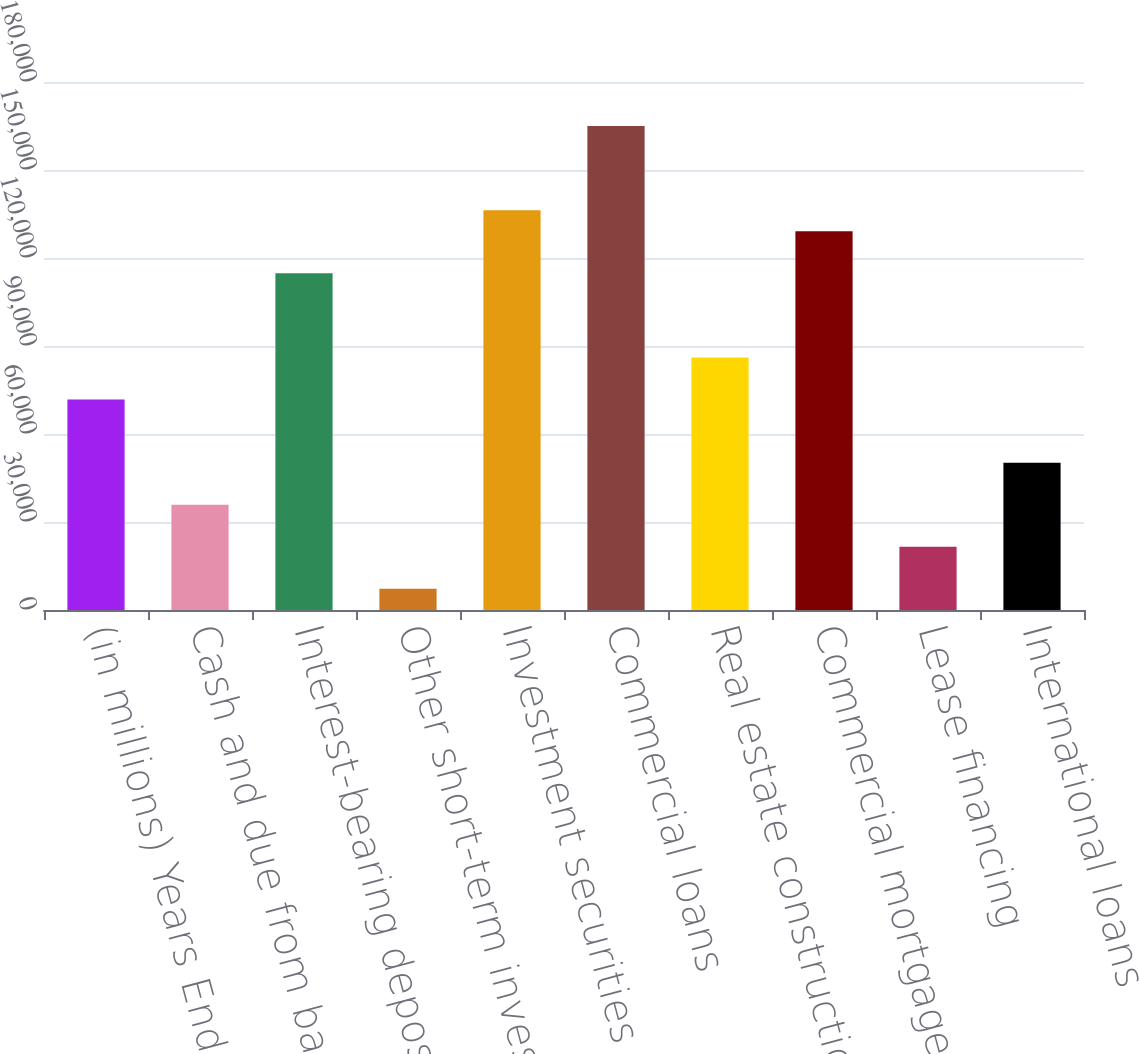Convert chart to OTSL. <chart><loc_0><loc_0><loc_500><loc_500><bar_chart><fcel>(in millions) Years Ended<fcel>Cash and due from banks<fcel>Interest-bearing deposits with<fcel>Other short-term investments<fcel>Investment securities<fcel>Commercial loans<fcel>Real estate construction loans<fcel>Commercial mortgage loans<fcel>Lease financing<fcel>International loans<nl><fcel>71743<fcel>35888<fcel>114769<fcel>7204<fcel>136282<fcel>164966<fcel>86085<fcel>129111<fcel>21546<fcel>50230<nl></chart> 